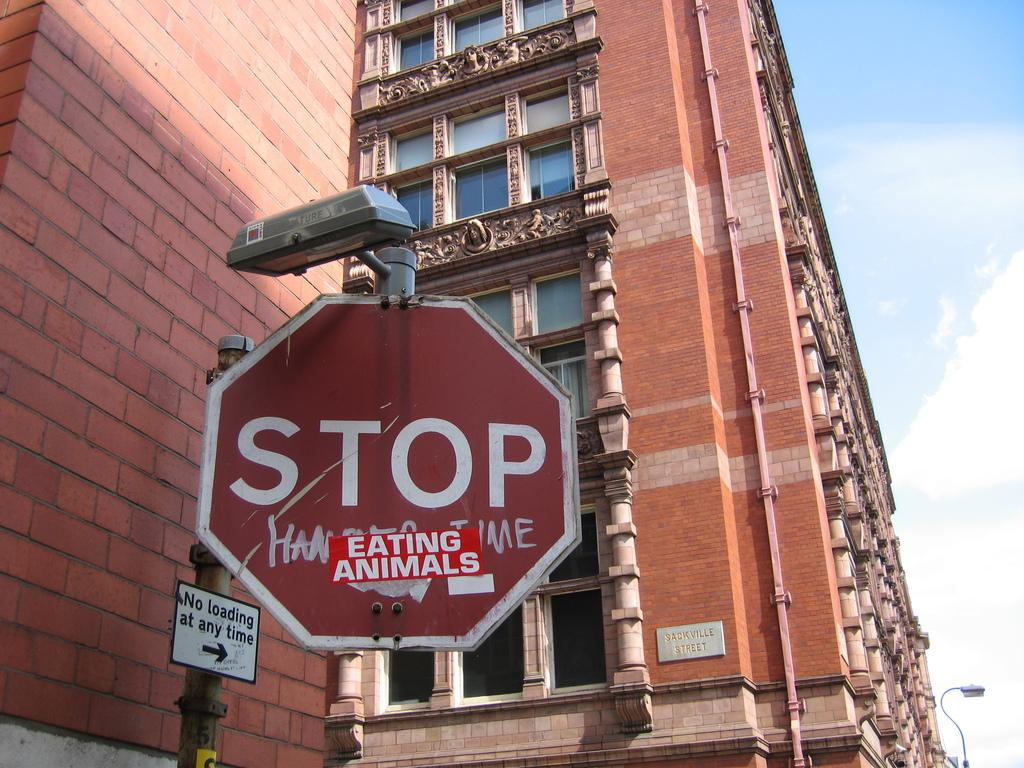<image>
Render a clear and concise summary of the photo. A big building with a stop sign that has a sticker saying eating animals. 